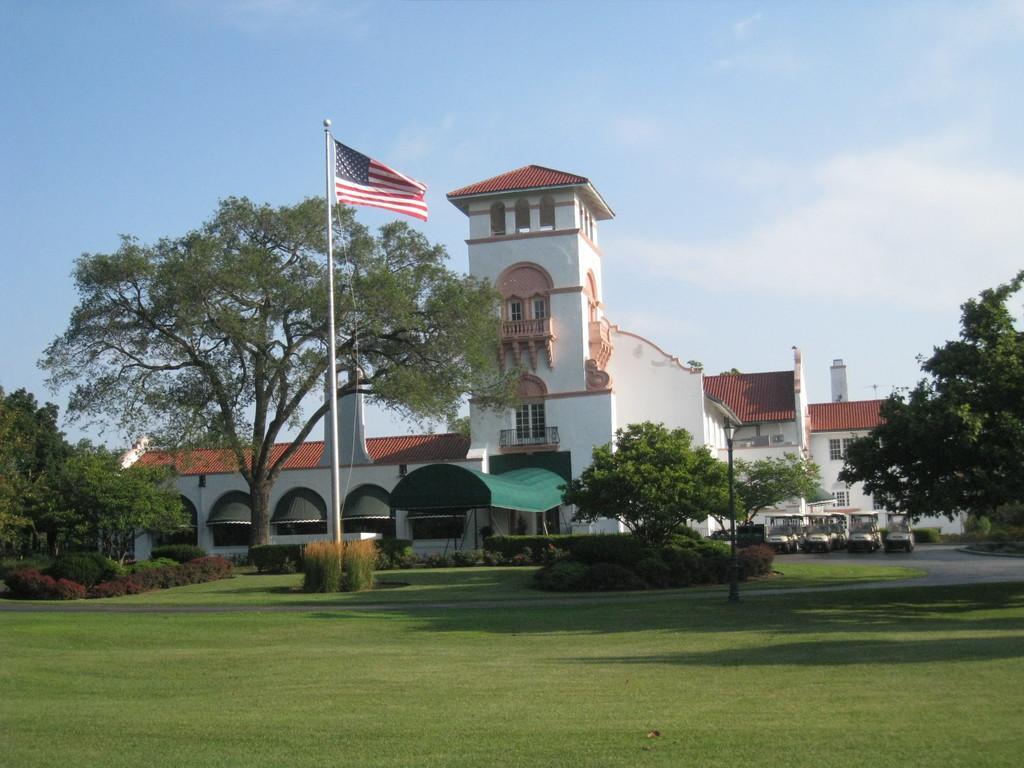What type of structure is present in the image? There is a building in the image. What natural elements can be seen in the image? There are trees, plants, grass, and clouds visible in the image. What man-made object is present in the image? There is a light pole in the image. What symbol can be seen in the image? There is a flag in the image. What mode of transportation is present in the image? There are vehicles in the image. What is visible in the background of the image? The sky is visible in the background of the image. Can you tell me how many lumber pieces are stacked near the building in the image? There is no mention of lumber in the image, so it is not possible to determine the number of lumber pieces present. What type of coat is the snail wearing in the image? There are no snails or coats present in the image. 